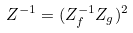Convert formula to latex. <formula><loc_0><loc_0><loc_500><loc_500>Z ^ { - 1 } = ( Z _ { f } ^ { - 1 } Z _ { g } ) ^ { 2 }</formula> 